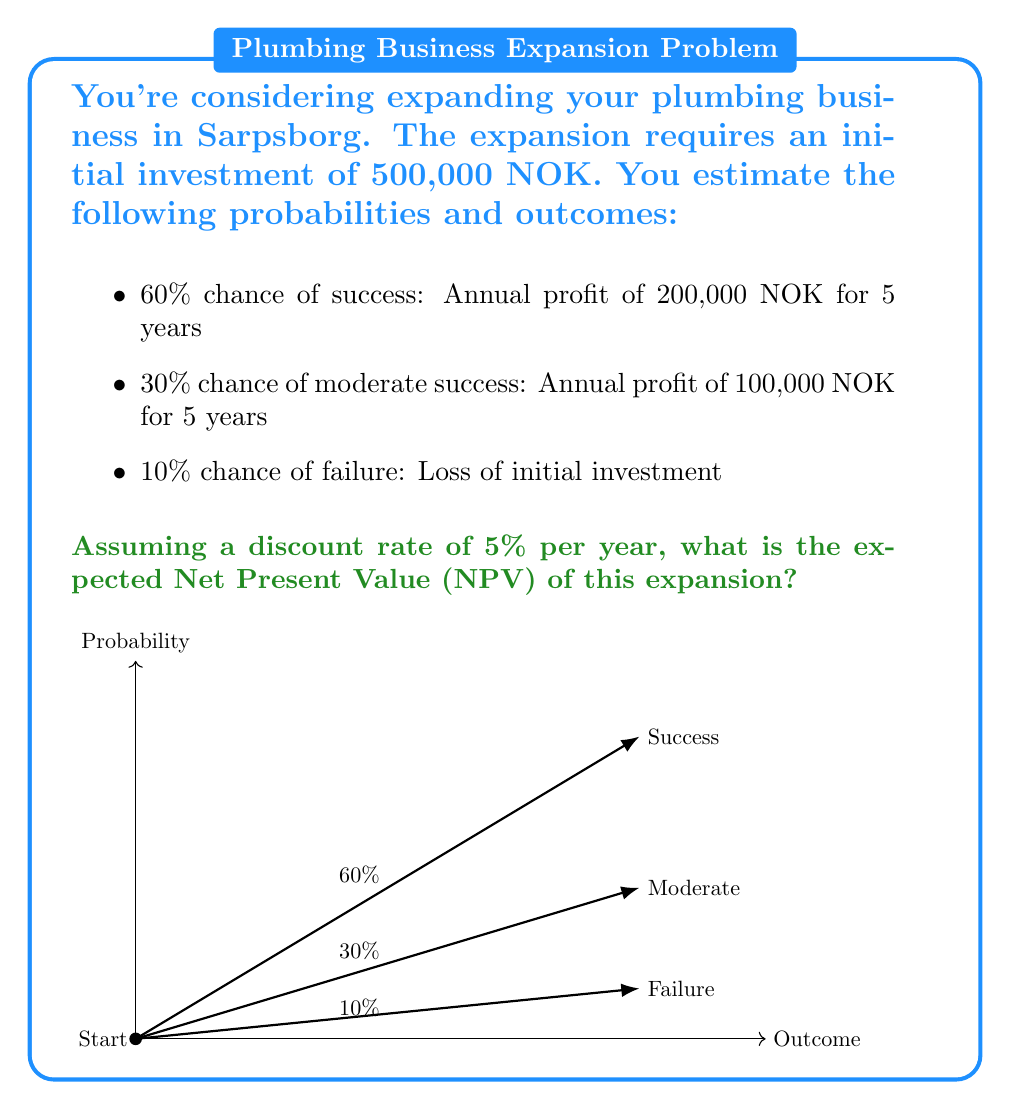Provide a solution to this math problem. Let's approach this step-by-step:

1) First, we need to calculate the Present Value (PV) of each outcome:

   For success and moderate success, we use the annuity formula:
   $$PV = A \cdot \frac{1 - (1+r)^{-n}}{r}$$
   where A is the annual cash flow, r is the discount rate, and n is the number of years.

2) For success:
   $$PV_{success} = 200,000 \cdot \frac{1 - (1.05)^{-5}}{0.05} = 866,432 \text{ NOK}$$

3) For moderate success:
   $$PV_{moderate} = 100,000 \cdot \frac{1 - (1.05)^{-5}}{0.05} = 433,216 \text{ NOK}$$

4) For failure, the PV is simply the loss of the initial investment:
   $$PV_{failure} = -500,000 \text{ NOK}$$

5) Now, we calculate the expected value of each outcome:
   $$E(success) = 0.6 \cdot (866,432 - 500,000) = 219,859 \text{ NOK}$$
   $$E(moderate) = 0.3 \cdot (433,216 - 500,000) = -20,035 \text{ NOK}$$
   $$E(failure) = 0.1 \cdot (-500,000) = -50,000 \text{ NOK}$$

6) The expected NPV is the sum of these expected values:
   $$E(NPV) = 219,859 - 20,035 - 50,000 = 149,824 \text{ NOK}$$
Answer: 149,824 NOK 